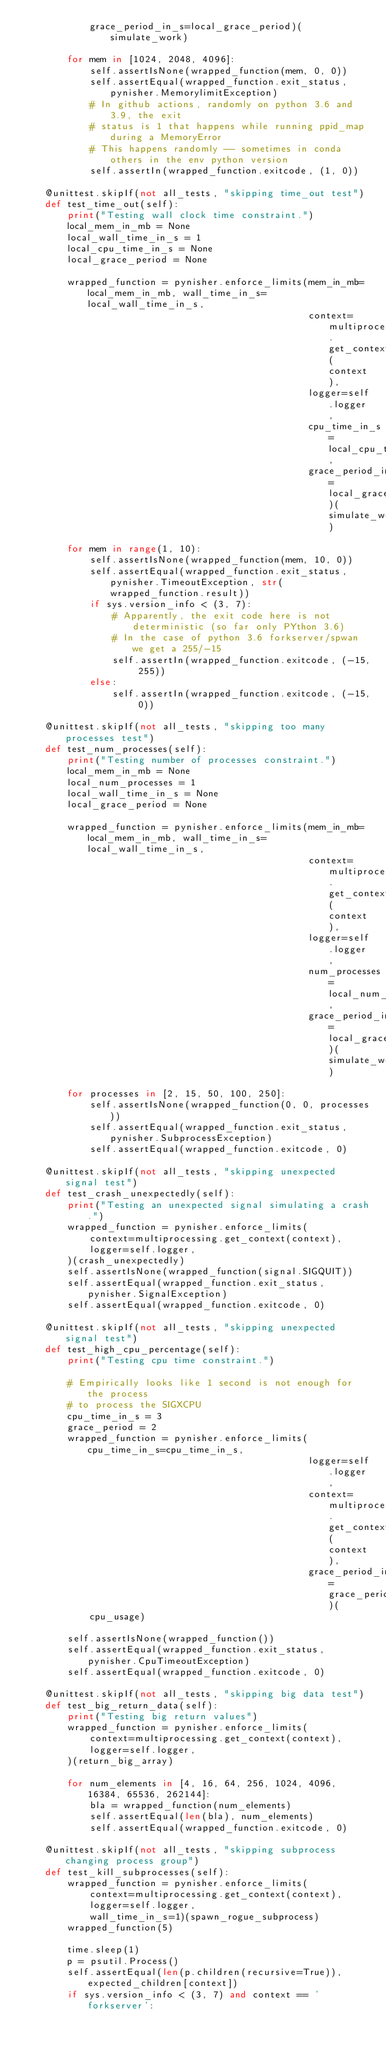Convert code to text. <code><loc_0><loc_0><loc_500><loc_500><_Python_>            grace_period_in_s=local_grace_period)(simulate_work)

        for mem in [1024, 2048, 4096]:
            self.assertIsNone(wrapped_function(mem, 0, 0))
            self.assertEqual(wrapped_function.exit_status, pynisher.MemorylimitException)
            # In github actions, randomly on python 3.6 and 3.9, the exit
            # status is 1 that happens while running ppid_map during a MemoryError
            # This happens randomly -- sometimes in conda others in the env python version
            self.assertIn(wrapped_function.exitcode, (1, 0))

    @unittest.skipIf(not all_tests, "skipping time_out test")
    def test_time_out(self):
        print("Testing wall clock time constraint.")
        local_mem_in_mb = None
        local_wall_time_in_s = 1
        local_cpu_time_in_s = None
        local_grace_period = None

        wrapped_function = pynisher.enforce_limits(mem_in_mb=local_mem_in_mb, wall_time_in_s=local_wall_time_in_s,
                                                   context=multiprocessing.get_context(context),
                                                   logger=self.logger,
                                                   cpu_time_in_s=local_cpu_time_in_s,
                                                   grace_period_in_s=local_grace_period)(simulate_work)

        for mem in range(1, 10):
            self.assertIsNone(wrapped_function(mem, 10, 0))
            self.assertEqual(wrapped_function.exit_status, pynisher.TimeoutException, str(wrapped_function.result))
            if sys.version_info < (3, 7):
                # Apparently, the exit code here is not deterministic (so far only PYthon 3.6)
                # In the case of python 3.6 forkserver/spwan we get a 255/-15
                self.assertIn(wrapped_function.exitcode, (-15, 255))
            else:
                self.assertIn(wrapped_function.exitcode, (-15, 0))

    @unittest.skipIf(not all_tests, "skipping too many processes test")
    def test_num_processes(self):
        print("Testing number of processes constraint.")
        local_mem_in_mb = None
        local_num_processes = 1
        local_wall_time_in_s = None
        local_grace_period = None

        wrapped_function = pynisher.enforce_limits(mem_in_mb=local_mem_in_mb, wall_time_in_s=local_wall_time_in_s,
                                                   context=multiprocessing.get_context(context),
                                                   logger=self.logger,
                                                   num_processes=local_num_processes,
                                                   grace_period_in_s=local_grace_period)(simulate_work)

        for processes in [2, 15, 50, 100, 250]:
            self.assertIsNone(wrapped_function(0, 0, processes))
            self.assertEqual(wrapped_function.exit_status, pynisher.SubprocessException)
            self.assertEqual(wrapped_function.exitcode, 0)

    @unittest.skipIf(not all_tests, "skipping unexpected signal test")
    def test_crash_unexpectedly(self):
        print("Testing an unexpected signal simulating a crash.")
        wrapped_function = pynisher.enforce_limits(
            context=multiprocessing.get_context(context),
            logger=self.logger,
        )(crash_unexpectedly)
        self.assertIsNone(wrapped_function(signal.SIGQUIT))
        self.assertEqual(wrapped_function.exit_status, pynisher.SignalException)
        self.assertEqual(wrapped_function.exitcode, 0)

    @unittest.skipIf(not all_tests, "skipping unexpected signal test")
    def test_high_cpu_percentage(self):
        print("Testing cpu time constraint.")

        # Empirically looks like 1 second is not enough for the process
        # to process the SIGXCPU
        cpu_time_in_s = 3
        grace_period = 2
        wrapped_function = pynisher.enforce_limits(cpu_time_in_s=cpu_time_in_s,
                                                   logger=self.logger,
                                                   context=multiprocessing.get_context(context),
                                                   grace_period_in_s=grace_period)(
            cpu_usage)

        self.assertIsNone(wrapped_function())
        self.assertEqual(wrapped_function.exit_status, pynisher.CpuTimeoutException)
        self.assertEqual(wrapped_function.exitcode, 0)

    @unittest.skipIf(not all_tests, "skipping big data test")
    def test_big_return_data(self):
        print("Testing big return values")
        wrapped_function = pynisher.enforce_limits(
            context=multiprocessing.get_context(context),
            logger=self.logger,
        )(return_big_array)

        for num_elements in [4, 16, 64, 256, 1024, 4096, 16384, 65536, 262144]:
            bla = wrapped_function(num_elements)
            self.assertEqual(len(bla), num_elements)
            self.assertEqual(wrapped_function.exitcode, 0)

    @unittest.skipIf(not all_tests, "skipping subprocess changing process group")
    def test_kill_subprocesses(self):
        wrapped_function = pynisher.enforce_limits(
            context=multiprocessing.get_context(context),
            logger=self.logger,
            wall_time_in_s=1)(spawn_rogue_subprocess)
        wrapped_function(5)

        time.sleep(1)
        p = psutil.Process()
        self.assertEqual(len(p.children(recursive=True)), expected_children[context])
        if sys.version_info < (3, 7) and context == 'forkserver':</code> 